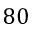<formula> <loc_0><loc_0><loc_500><loc_500>8 0</formula> 